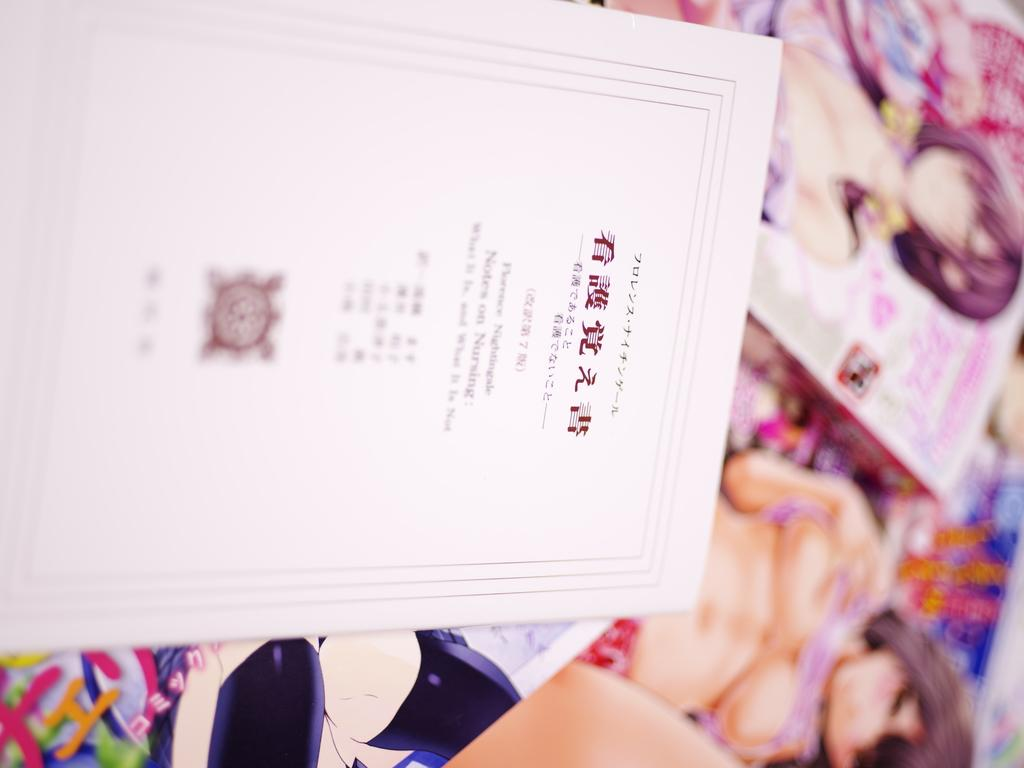What is the main object in the image? There is a card in the image. Are there any other objects related to the card? Yes, there are boxes in the image. What type of car is shown on the page of the card in the image? There is no car or page mentioned in the image; it only contains a card and boxes. 